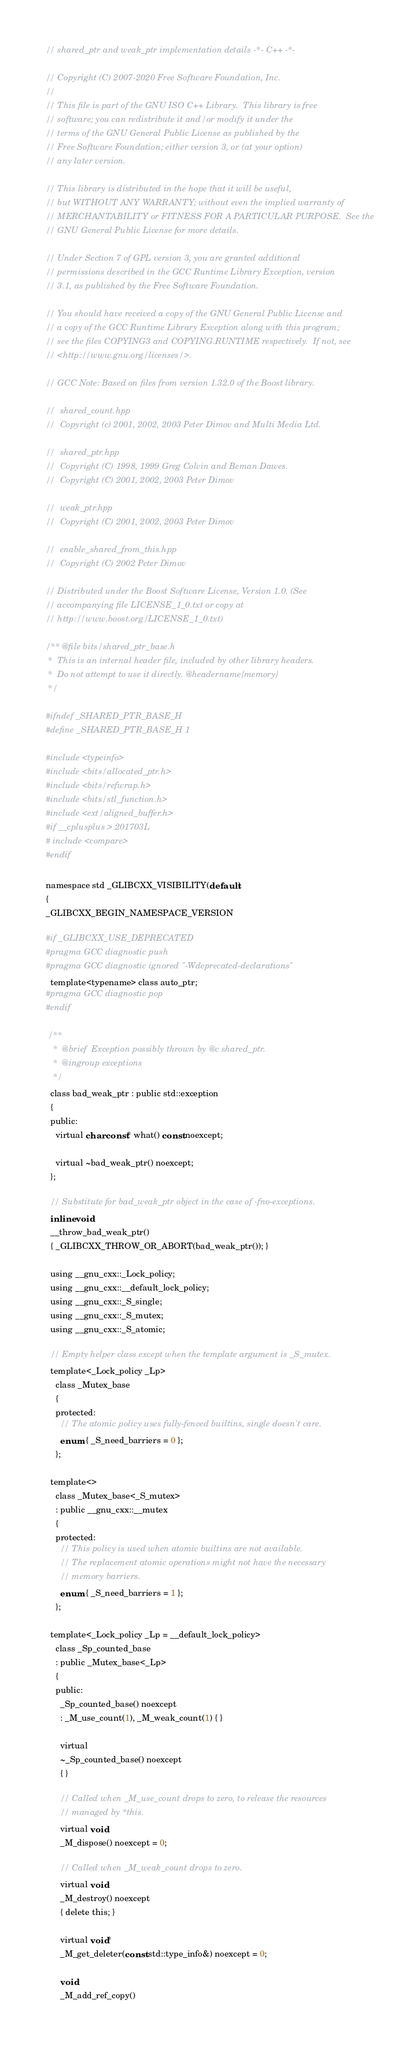Convert code to text. <code><loc_0><loc_0><loc_500><loc_500><_C_>// shared_ptr and weak_ptr implementation details -*- C++ -*-

// Copyright (C) 2007-2020 Free Software Foundation, Inc.
//
// This file is part of the GNU ISO C++ Library.  This library is free
// software; you can redistribute it and/or modify it under the
// terms of the GNU General Public License as published by the
// Free Software Foundation; either version 3, or (at your option)
// any later version.

// This library is distributed in the hope that it will be useful,
// but WITHOUT ANY WARRANTY; without even the implied warranty of
// MERCHANTABILITY or FITNESS FOR A PARTICULAR PURPOSE.  See the
// GNU General Public License for more details.

// Under Section 7 of GPL version 3, you are granted additional
// permissions described in the GCC Runtime Library Exception, version
// 3.1, as published by the Free Software Foundation.

// You should have received a copy of the GNU General Public License and
// a copy of the GCC Runtime Library Exception along with this program;
// see the files COPYING3 and COPYING.RUNTIME respectively.  If not, see
// <http://www.gnu.org/licenses/>.

// GCC Note: Based on files from version 1.32.0 of the Boost library.

//  shared_count.hpp
//  Copyright (c) 2001, 2002, 2003 Peter Dimov and Multi Media Ltd.

//  shared_ptr.hpp
//  Copyright (C) 1998, 1999 Greg Colvin and Beman Dawes.
//  Copyright (C) 2001, 2002, 2003 Peter Dimov

//  weak_ptr.hpp
//  Copyright (C) 2001, 2002, 2003 Peter Dimov

//  enable_shared_from_this.hpp
//  Copyright (C) 2002 Peter Dimov

// Distributed under the Boost Software License, Version 1.0. (See
// accompanying file LICENSE_1_0.txt or copy at
// http://www.boost.org/LICENSE_1_0.txt)

/** @file bits/shared_ptr_base.h
 *  This is an internal header file, included by other library headers.
 *  Do not attempt to use it directly. @headername{memory}
 */

#ifndef _SHARED_PTR_BASE_H
#define _SHARED_PTR_BASE_H 1

#include <typeinfo>
#include <bits/allocated_ptr.h>
#include <bits/refwrap.h>
#include <bits/stl_function.h>
#include <ext/aligned_buffer.h>
#if __cplusplus > 201703L
# include <compare>
#endif

namespace std _GLIBCXX_VISIBILITY(default)
{
_GLIBCXX_BEGIN_NAMESPACE_VERSION

#if _GLIBCXX_USE_DEPRECATED
#pragma GCC diagnostic push
#pragma GCC diagnostic ignored "-Wdeprecated-declarations"
  template<typename> class auto_ptr;
#pragma GCC diagnostic pop
#endif

 /**
   *  @brief  Exception possibly thrown by @c shared_ptr.
   *  @ingroup exceptions
   */
  class bad_weak_ptr : public std::exception
  {
  public:
    virtual char const* what() const noexcept;

    virtual ~bad_weak_ptr() noexcept;
  };

  // Substitute for bad_weak_ptr object in the case of -fno-exceptions.
  inline void
  __throw_bad_weak_ptr()
  { _GLIBCXX_THROW_OR_ABORT(bad_weak_ptr()); }

  using __gnu_cxx::_Lock_policy;
  using __gnu_cxx::__default_lock_policy;
  using __gnu_cxx::_S_single;
  using __gnu_cxx::_S_mutex;
  using __gnu_cxx::_S_atomic;

  // Empty helper class except when the template argument is _S_mutex.
  template<_Lock_policy _Lp>
    class _Mutex_base
    {
    protected:
      // The atomic policy uses fully-fenced builtins, single doesn't care.
      enum { _S_need_barriers = 0 };
    };

  template<>
    class _Mutex_base<_S_mutex>
    : public __gnu_cxx::__mutex
    {
    protected:
      // This policy is used when atomic builtins are not available.
      // The replacement atomic operations might not have the necessary
      // memory barriers.
      enum { _S_need_barriers = 1 };
    };

  template<_Lock_policy _Lp = __default_lock_policy>
    class _Sp_counted_base
    : public _Mutex_base<_Lp>
    {
    public:
      _Sp_counted_base() noexcept
      : _M_use_count(1), _M_weak_count(1) { }

      virtual
      ~_Sp_counted_base() noexcept
      { }

      // Called when _M_use_count drops to zero, to release the resources
      // managed by *this.
      virtual void
      _M_dispose() noexcept = 0;

      // Called when _M_weak_count drops to zero.
      virtual void
      _M_destroy() noexcept
      { delete this; }

      virtual void*
      _M_get_deleter(const std::type_info&) noexcept = 0;

      void
      _M_add_ref_copy()</code> 